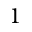<formula> <loc_0><loc_0><loc_500><loc_500>1</formula> 